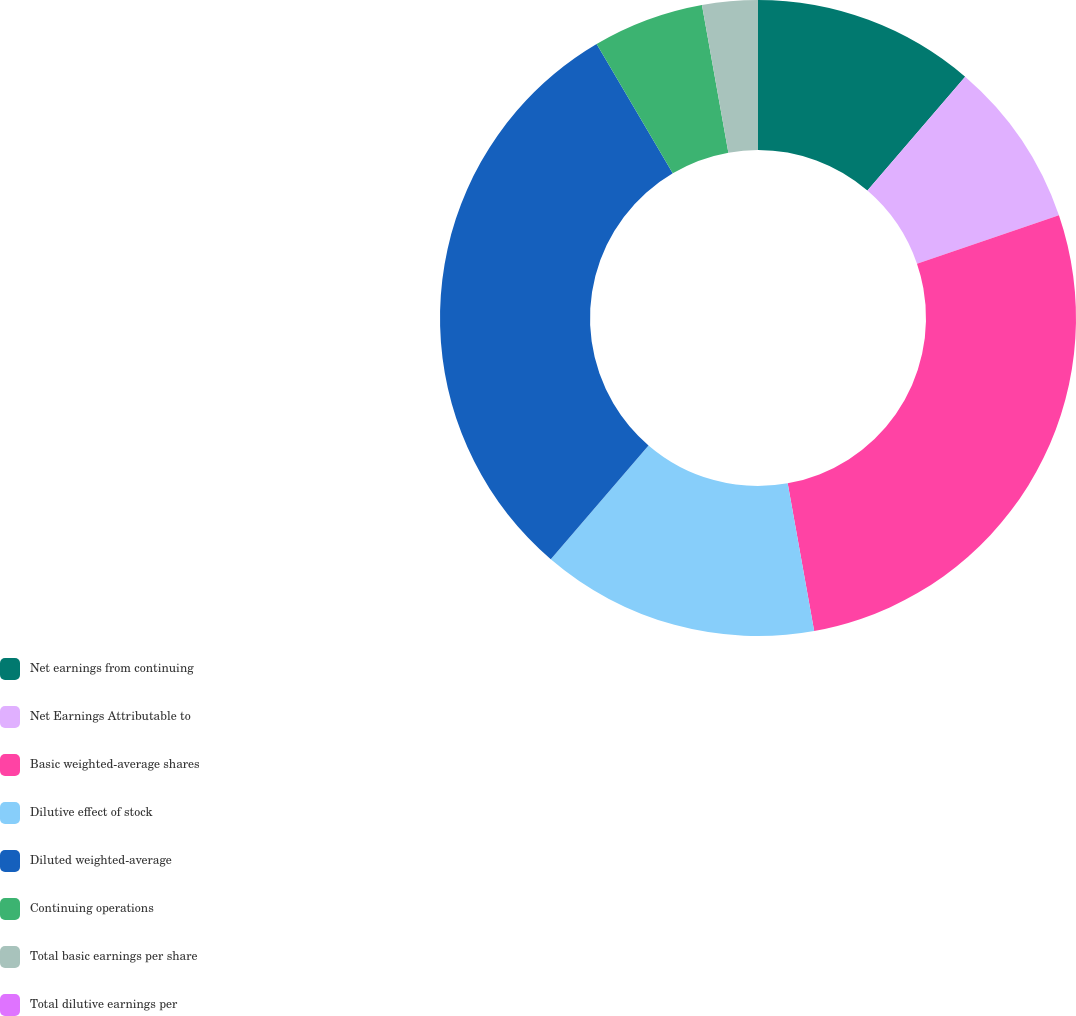<chart> <loc_0><loc_0><loc_500><loc_500><pie_chart><fcel>Net earnings from continuing<fcel>Net Earnings Attributable to<fcel>Basic weighted-average shares<fcel>Dilutive effect of stock<fcel>Diluted weighted-average<fcel>Continuing operations<fcel>Total basic earnings per share<fcel>Total dilutive earnings per<nl><fcel>11.29%<fcel>8.47%<fcel>27.41%<fcel>14.12%<fcel>30.23%<fcel>5.65%<fcel>2.82%<fcel>0.0%<nl></chart> 